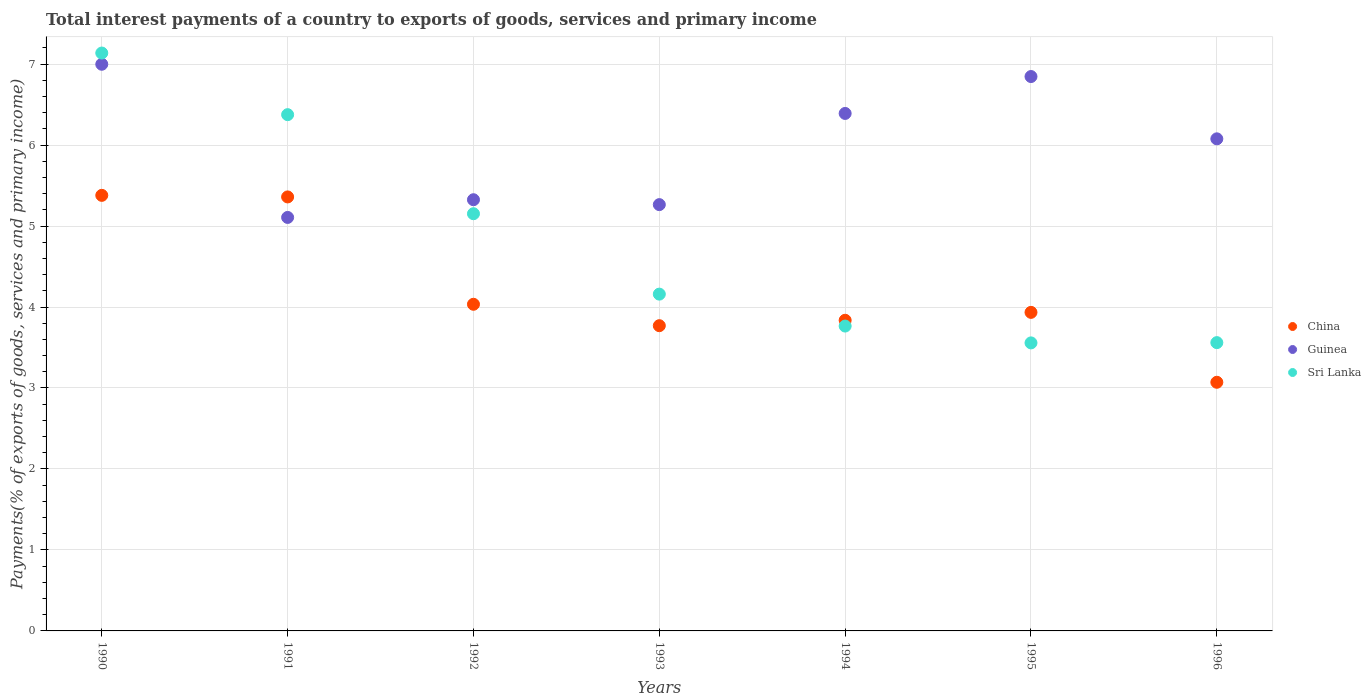How many different coloured dotlines are there?
Provide a succinct answer. 3. Is the number of dotlines equal to the number of legend labels?
Your answer should be very brief. Yes. What is the total interest payments in Sri Lanka in 1990?
Provide a succinct answer. 7.14. Across all years, what is the maximum total interest payments in Sri Lanka?
Provide a succinct answer. 7.14. Across all years, what is the minimum total interest payments in Sri Lanka?
Provide a short and direct response. 3.56. In which year was the total interest payments in Sri Lanka minimum?
Give a very brief answer. 1995. What is the total total interest payments in Guinea in the graph?
Keep it short and to the point. 42.01. What is the difference between the total interest payments in China in 1991 and that in 1993?
Provide a succinct answer. 1.59. What is the difference between the total interest payments in China in 1994 and the total interest payments in Sri Lanka in 1992?
Give a very brief answer. -1.32. What is the average total interest payments in Sri Lanka per year?
Your response must be concise. 4.81. In the year 1994, what is the difference between the total interest payments in China and total interest payments in Guinea?
Your response must be concise. -2.55. In how many years, is the total interest payments in Sri Lanka greater than 5 %?
Offer a very short reply. 3. What is the ratio of the total interest payments in Sri Lanka in 1990 to that in 1992?
Your answer should be compact. 1.39. Is the difference between the total interest payments in China in 1993 and 1995 greater than the difference between the total interest payments in Guinea in 1993 and 1995?
Give a very brief answer. Yes. What is the difference between the highest and the second highest total interest payments in Sri Lanka?
Ensure brevity in your answer.  0.76. What is the difference between the highest and the lowest total interest payments in China?
Make the answer very short. 2.31. In how many years, is the total interest payments in China greater than the average total interest payments in China taken over all years?
Your answer should be compact. 2. Does the total interest payments in Sri Lanka monotonically increase over the years?
Make the answer very short. No. Is the total interest payments in Sri Lanka strictly greater than the total interest payments in Guinea over the years?
Provide a succinct answer. No. How many dotlines are there?
Your answer should be very brief. 3. Are the values on the major ticks of Y-axis written in scientific E-notation?
Keep it short and to the point. No. Does the graph contain any zero values?
Ensure brevity in your answer.  No. Does the graph contain grids?
Provide a succinct answer. Yes. Where does the legend appear in the graph?
Give a very brief answer. Center right. How are the legend labels stacked?
Make the answer very short. Vertical. What is the title of the graph?
Offer a terse response. Total interest payments of a country to exports of goods, services and primary income. Does "Afghanistan" appear as one of the legend labels in the graph?
Your answer should be compact. No. What is the label or title of the X-axis?
Make the answer very short. Years. What is the label or title of the Y-axis?
Ensure brevity in your answer.  Payments(% of exports of goods, services and primary income). What is the Payments(% of exports of goods, services and primary income) in China in 1990?
Your answer should be compact. 5.38. What is the Payments(% of exports of goods, services and primary income) of Guinea in 1990?
Offer a terse response. 7. What is the Payments(% of exports of goods, services and primary income) of Sri Lanka in 1990?
Give a very brief answer. 7.14. What is the Payments(% of exports of goods, services and primary income) of China in 1991?
Provide a succinct answer. 5.36. What is the Payments(% of exports of goods, services and primary income) in Guinea in 1991?
Provide a succinct answer. 5.11. What is the Payments(% of exports of goods, services and primary income) in Sri Lanka in 1991?
Your answer should be very brief. 6.38. What is the Payments(% of exports of goods, services and primary income) in China in 1992?
Keep it short and to the point. 4.03. What is the Payments(% of exports of goods, services and primary income) in Guinea in 1992?
Offer a very short reply. 5.32. What is the Payments(% of exports of goods, services and primary income) of Sri Lanka in 1992?
Keep it short and to the point. 5.15. What is the Payments(% of exports of goods, services and primary income) in China in 1993?
Give a very brief answer. 3.77. What is the Payments(% of exports of goods, services and primary income) in Guinea in 1993?
Make the answer very short. 5.26. What is the Payments(% of exports of goods, services and primary income) of Sri Lanka in 1993?
Offer a very short reply. 4.16. What is the Payments(% of exports of goods, services and primary income) of China in 1994?
Provide a succinct answer. 3.84. What is the Payments(% of exports of goods, services and primary income) of Guinea in 1994?
Your answer should be very brief. 6.39. What is the Payments(% of exports of goods, services and primary income) of Sri Lanka in 1994?
Your answer should be compact. 3.76. What is the Payments(% of exports of goods, services and primary income) of China in 1995?
Offer a very short reply. 3.93. What is the Payments(% of exports of goods, services and primary income) in Guinea in 1995?
Give a very brief answer. 6.85. What is the Payments(% of exports of goods, services and primary income) of Sri Lanka in 1995?
Your answer should be compact. 3.56. What is the Payments(% of exports of goods, services and primary income) in China in 1996?
Give a very brief answer. 3.07. What is the Payments(% of exports of goods, services and primary income) of Guinea in 1996?
Offer a very short reply. 6.08. What is the Payments(% of exports of goods, services and primary income) in Sri Lanka in 1996?
Your response must be concise. 3.56. Across all years, what is the maximum Payments(% of exports of goods, services and primary income) in China?
Provide a succinct answer. 5.38. Across all years, what is the maximum Payments(% of exports of goods, services and primary income) of Guinea?
Offer a very short reply. 7. Across all years, what is the maximum Payments(% of exports of goods, services and primary income) in Sri Lanka?
Your response must be concise. 7.14. Across all years, what is the minimum Payments(% of exports of goods, services and primary income) in China?
Provide a short and direct response. 3.07. Across all years, what is the minimum Payments(% of exports of goods, services and primary income) of Guinea?
Ensure brevity in your answer.  5.11. Across all years, what is the minimum Payments(% of exports of goods, services and primary income) in Sri Lanka?
Your response must be concise. 3.56. What is the total Payments(% of exports of goods, services and primary income) of China in the graph?
Ensure brevity in your answer.  29.38. What is the total Payments(% of exports of goods, services and primary income) of Guinea in the graph?
Make the answer very short. 42.01. What is the total Payments(% of exports of goods, services and primary income) in Sri Lanka in the graph?
Give a very brief answer. 33.7. What is the difference between the Payments(% of exports of goods, services and primary income) of China in 1990 and that in 1991?
Ensure brevity in your answer.  0.02. What is the difference between the Payments(% of exports of goods, services and primary income) of Guinea in 1990 and that in 1991?
Provide a succinct answer. 1.89. What is the difference between the Payments(% of exports of goods, services and primary income) in Sri Lanka in 1990 and that in 1991?
Offer a terse response. 0.76. What is the difference between the Payments(% of exports of goods, services and primary income) of China in 1990 and that in 1992?
Ensure brevity in your answer.  1.34. What is the difference between the Payments(% of exports of goods, services and primary income) in Guinea in 1990 and that in 1992?
Ensure brevity in your answer.  1.67. What is the difference between the Payments(% of exports of goods, services and primary income) in Sri Lanka in 1990 and that in 1992?
Keep it short and to the point. 1.98. What is the difference between the Payments(% of exports of goods, services and primary income) in China in 1990 and that in 1993?
Ensure brevity in your answer.  1.61. What is the difference between the Payments(% of exports of goods, services and primary income) in Guinea in 1990 and that in 1993?
Keep it short and to the point. 1.73. What is the difference between the Payments(% of exports of goods, services and primary income) in Sri Lanka in 1990 and that in 1993?
Give a very brief answer. 2.98. What is the difference between the Payments(% of exports of goods, services and primary income) of China in 1990 and that in 1994?
Give a very brief answer. 1.54. What is the difference between the Payments(% of exports of goods, services and primary income) in Guinea in 1990 and that in 1994?
Your answer should be compact. 0.61. What is the difference between the Payments(% of exports of goods, services and primary income) in Sri Lanka in 1990 and that in 1994?
Ensure brevity in your answer.  3.37. What is the difference between the Payments(% of exports of goods, services and primary income) in China in 1990 and that in 1995?
Make the answer very short. 1.45. What is the difference between the Payments(% of exports of goods, services and primary income) in Guinea in 1990 and that in 1995?
Give a very brief answer. 0.15. What is the difference between the Payments(% of exports of goods, services and primary income) of Sri Lanka in 1990 and that in 1995?
Your answer should be very brief. 3.58. What is the difference between the Payments(% of exports of goods, services and primary income) of China in 1990 and that in 1996?
Ensure brevity in your answer.  2.31. What is the difference between the Payments(% of exports of goods, services and primary income) of Guinea in 1990 and that in 1996?
Provide a succinct answer. 0.92. What is the difference between the Payments(% of exports of goods, services and primary income) in Sri Lanka in 1990 and that in 1996?
Keep it short and to the point. 3.58. What is the difference between the Payments(% of exports of goods, services and primary income) in China in 1991 and that in 1992?
Your response must be concise. 1.33. What is the difference between the Payments(% of exports of goods, services and primary income) in Guinea in 1991 and that in 1992?
Give a very brief answer. -0.22. What is the difference between the Payments(% of exports of goods, services and primary income) of Sri Lanka in 1991 and that in 1992?
Provide a succinct answer. 1.22. What is the difference between the Payments(% of exports of goods, services and primary income) of China in 1991 and that in 1993?
Offer a very short reply. 1.59. What is the difference between the Payments(% of exports of goods, services and primary income) in Guinea in 1991 and that in 1993?
Give a very brief answer. -0.16. What is the difference between the Payments(% of exports of goods, services and primary income) of Sri Lanka in 1991 and that in 1993?
Provide a succinct answer. 2.22. What is the difference between the Payments(% of exports of goods, services and primary income) of China in 1991 and that in 1994?
Ensure brevity in your answer.  1.52. What is the difference between the Payments(% of exports of goods, services and primary income) in Guinea in 1991 and that in 1994?
Provide a succinct answer. -1.28. What is the difference between the Payments(% of exports of goods, services and primary income) in Sri Lanka in 1991 and that in 1994?
Your answer should be very brief. 2.61. What is the difference between the Payments(% of exports of goods, services and primary income) of China in 1991 and that in 1995?
Your response must be concise. 1.43. What is the difference between the Payments(% of exports of goods, services and primary income) in Guinea in 1991 and that in 1995?
Offer a very short reply. -1.74. What is the difference between the Payments(% of exports of goods, services and primary income) of Sri Lanka in 1991 and that in 1995?
Provide a succinct answer. 2.82. What is the difference between the Payments(% of exports of goods, services and primary income) of China in 1991 and that in 1996?
Keep it short and to the point. 2.29. What is the difference between the Payments(% of exports of goods, services and primary income) in Guinea in 1991 and that in 1996?
Your answer should be compact. -0.97. What is the difference between the Payments(% of exports of goods, services and primary income) of Sri Lanka in 1991 and that in 1996?
Your response must be concise. 2.82. What is the difference between the Payments(% of exports of goods, services and primary income) in China in 1992 and that in 1993?
Provide a succinct answer. 0.26. What is the difference between the Payments(% of exports of goods, services and primary income) of Guinea in 1992 and that in 1993?
Offer a terse response. 0.06. What is the difference between the Payments(% of exports of goods, services and primary income) of Sri Lanka in 1992 and that in 1993?
Provide a short and direct response. 0.99. What is the difference between the Payments(% of exports of goods, services and primary income) in China in 1992 and that in 1994?
Your answer should be compact. 0.2. What is the difference between the Payments(% of exports of goods, services and primary income) of Guinea in 1992 and that in 1994?
Provide a short and direct response. -1.07. What is the difference between the Payments(% of exports of goods, services and primary income) in Sri Lanka in 1992 and that in 1994?
Ensure brevity in your answer.  1.39. What is the difference between the Payments(% of exports of goods, services and primary income) of China in 1992 and that in 1995?
Your response must be concise. 0.1. What is the difference between the Payments(% of exports of goods, services and primary income) of Guinea in 1992 and that in 1995?
Make the answer very short. -1.52. What is the difference between the Payments(% of exports of goods, services and primary income) of Sri Lanka in 1992 and that in 1995?
Your answer should be very brief. 1.6. What is the difference between the Payments(% of exports of goods, services and primary income) of China in 1992 and that in 1996?
Offer a very short reply. 0.96. What is the difference between the Payments(% of exports of goods, services and primary income) of Guinea in 1992 and that in 1996?
Give a very brief answer. -0.75. What is the difference between the Payments(% of exports of goods, services and primary income) in Sri Lanka in 1992 and that in 1996?
Offer a terse response. 1.59. What is the difference between the Payments(% of exports of goods, services and primary income) of China in 1993 and that in 1994?
Offer a terse response. -0.07. What is the difference between the Payments(% of exports of goods, services and primary income) in Guinea in 1993 and that in 1994?
Your answer should be very brief. -1.13. What is the difference between the Payments(% of exports of goods, services and primary income) of Sri Lanka in 1993 and that in 1994?
Your response must be concise. 0.39. What is the difference between the Payments(% of exports of goods, services and primary income) of China in 1993 and that in 1995?
Offer a terse response. -0.16. What is the difference between the Payments(% of exports of goods, services and primary income) of Guinea in 1993 and that in 1995?
Provide a short and direct response. -1.58. What is the difference between the Payments(% of exports of goods, services and primary income) of Sri Lanka in 1993 and that in 1995?
Your answer should be very brief. 0.6. What is the difference between the Payments(% of exports of goods, services and primary income) of China in 1993 and that in 1996?
Offer a very short reply. 0.7. What is the difference between the Payments(% of exports of goods, services and primary income) of Guinea in 1993 and that in 1996?
Offer a terse response. -0.81. What is the difference between the Payments(% of exports of goods, services and primary income) in Sri Lanka in 1993 and that in 1996?
Give a very brief answer. 0.6. What is the difference between the Payments(% of exports of goods, services and primary income) in China in 1994 and that in 1995?
Give a very brief answer. -0.1. What is the difference between the Payments(% of exports of goods, services and primary income) of Guinea in 1994 and that in 1995?
Ensure brevity in your answer.  -0.46. What is the difference between the Payments(% of exports of goods, services and primary income) in Sri Lanka in 1994 and that in 1995?
Give a very brief answer. 0.21. What is the difference between the Payments(% of exports of goods, services and primary income) in China in 1994 and that in 1996?
Your answer should be very brief. 0.77. What is the difference between the Payments(% of exports of goods, services and primary income) of Guinea in 1994 and that in 1996?
Your answer should be compact. 0.31. What is the difference between the Payments(% of exports of goods, services and primary income) of Sri Lanka in 1994 and that in 1996?
Make the answer very short. 0.2. What is the difference between the Payments(% of exports of goods, services and primary income) in China in 1995 and that in 1996?
Provide a short and direct response. 0.86. What is the difference between the Payments(% of exports of goods, services and primary income) of Guinea in 1995 and that in 1996?
Offer a terse response. 0.77. What is the difference between the Payments(% of exports of goods, services and primary income) of Sri Lanka in 1995 and that in 1996?
Provide a succinct answer. -0. What is the difference between the Payments(% of exports of goods, services and primary income) in China in 1990 and the Payments(% of exports of goods, services and primary income) in Guinea in 1991?
Your answer should be very brief. 0.27. What is the difference between the Payments(% of exports of goods, services and primary income) in China in 1990 and the Payments(% of exports of goods, services and primary income) in Sri Lanka in 1991?
Ensure brevity in your answer.  -1. What is the difference between the Payments(% of exports of goods, services and primary income) of Guinea in 1990 and the Payments(% of exports of goods, services and primary income) of Sri Lanka in 1991?
Your answer should be very brief. 0.62. What is the difference between the Payments(% of exports of goods, services and primary income) in China in 1990 and the Payments(% of exports of goods, services and primary income) in Guinea in 1992?
Offer a very short reply. 0.05. What is the difference between the Payments(% of exports of goods, services and primary income) in China in 1990 and the Payments(% of exports of goods, services and primary income) in Sri Lanka in 1992?
Provide a succinct answer. 0.23. What is the difference between the Payments(% of exports of goods, services and primary income) of Guinea in 1990 and the Payments(% of exports of goods, services and primary income) of Sri Lanka in 1992?
Your response must be concise. 1.85. What is the difference between the Payments(% of exports of goods, services and primary income) in China in 1990 and the Payments(% of exports of goods, services and primary income) in Guinea in 1993?
Keep it short and to the point. 0.11. What is the difference between the Payments(% of exports of goods, services and primary income) in China in 1990 and the Payments(% of exports of goods, services and primary income) in Sri Lanka in 1993?
Your response must be concise. 1.22. What is the difference between the Payments(% of exports of goods, services and primary income) in Guinea in 1990 and the Payments(% of exports of goods, services and primary income) in Sri Lanka in 1993?
Keep it short and to the point. 2.84. What is the difference between the Payments(% of exports of goods, services and primary income) in China in 1990 and the Payments(% of exports of goods, services and primary income) in Guinea in 1994?
Offer a terse response. -1.01. What is the difference between the Payments(% of exports of goods, services and primary income) in China in 1990 and the Payments(% of exports of goods, services and primary income) in Sri Lanka in 1994?
Give a very brief answer. 1.61. What is the difference between the Payments(% of exports of goods, services and primary income) in Guinea in 1990 and the Payments(% of exports of goods, services and primary income) in Sri Lanka in 1994?
Provide a succinct answer. 3.23. What is the difference between the Payments(% of exports of goods, services and primary income) of China in 1990 and the Payments(% of exports of goods, services and primary income) of Guinea in 1995?
Provide a short and direct response. -1.47. What is the difference between the Payments(% of exports of goods, services and primary income) in China in 1990 and the Payments(% of exports of goods, services and primary income) in Sri Lanka in 1995?
Keep it short and to the point. 1.82. What is the difference between the Payments(% of exports of goods, services and primary income) of Guinea in 1990 and the Payments(% of exports of goods, services and primary income) of Sri Lanka in 1995?
Provide a short and direct response. 3.44. What is the difference between the Payments(% of exports of goods, services and primary income) of China in 1990 and the Payments(% of exports of goods, services and primary income) of Guinea in 1996?
Provide a succinct answer. -0.7. What is the difference between the Payments(% of exports of goods, services and primary income) of China in 1990 and the Payments(% of exports of goods, services and primary income) of Sri Lanka in 1996?
Your answer should be very brief. 1.82. What is the difference between the Payments(% of exports of goods, services and primary income) in Guinea in 1990 and the Payments(% of exports of goods, services and primary income) in Sri Lanka in 1996?
Give a very brief answer. 3.44. What is the difference between the Payments(% of exports of goods, services and primary income) in China in 1991 and the Payments(% of exports of goods, services and primary income) in Guinea in 1992?
Keep it short and to the point. 0.03. What is the difference between the Payments(% of exports of goods, services and primary income) in China in 1991 and the Payments(% of exports of goods, services and primary income) in Sri Lanka in 1992?
Your answer should be very brief. 0.21. What is the difference between the Payments(% of exports of goods, services and primary income) of Guinea in 1991 and the Payments(% of exports of goods, services and primary income) of Sri Lanka in 1992?
Keep it short and to the point. -0.05. What is the difference between the Payments(% of exports of goods, services and primary income) of China in 1991 and the Payments(% of exports of goods, services and primary income) of Guinea in 1993?
Provide a short and direct response. 0.1. What is the difference between the Payments(% of exports of goods, services and primary income) of China in 1991 and the Payments(% of exports of goods, services and primary income) of Sri Lanka in 1993?
Offer a terse response. 1.2. What is the difference between the Payments(% of exports of goods, services and primary income) of Guinea in 1991 and the Payments(% of exports of goods, services and primary income) of Sri Lanka in 1993?
Offer a very short reply. 0.95. What is the difference between the Payments(% of exports of goods, services and primary income) of China in 1991 and the Payments(% of exports of goods, services and primary income) of Guinea in 1994?
Your answer should be compact. -1.03. What is the difference between the Payments(% of exports of goods, services and primary income) of China in 1991 and the Payments(% of exports of goods, services and primary income) of Sri Lanka in 1994?
Give a very brief answer. 1.59. What is the difference between the Payments(% of exports of goods, services and primary income) in Guinea in 1991 and the Payments(% of exports of goods, services and primary income) in Sri Lanka in 1994?
Provide a short and direct response. 1.34. What is the difference between the Payments(% of exports of goods, services and primary income) of China in 1991 and the Payments(% of exports of goods, services and primary income) of Guinea in 1995?
Your response must be concise. -1.49. What is the difference between the Payments(% of exports of goods, services and primary income) in China in 1991 and the Payments(% of exports of goods, services and primary income) in Sri Lanka in 1995?
Provide a short and direct response. 1.8. What is the difference between the Payments(% of exports of goods, services and primary income) in Guinea in 1991 and the Payments(% of exports of goods, services and primary income) in Sri Lanka in 1995?
Offer a terse response. 1.55. What is the difference between the Payments(% of exports of goods, services and primary income) of China in 1991 and the Payments(% of exports of goods, services and primary income) of Guinea in 1996?
Provide a short and direct response. -0.72. What is the difference between the Payments(% of exports of goods, services and primary income) of China in 1991 and the Payments(% of exports of goods, services and primary income) of Sri Lanka in 1996?
Make the answer very short. 1.8. What is the difference between the Payments(% of exports of goods, services and primary income) in Guinea in 1991 and the Payments(% of exports of goods, services and primary income) in Sri Lanka in 1996?
Ensure brevity in your answer.  1.55. What is the difference between the Payments(% of exports of goods, services and primary income) of China in 1992 and the Payments(% of exports of goods, services and primary income) of Guinea in 1993?
Provide a succinct answer. -1.23. What is the difference between the Payments(% of exports of goods, services and primary income) in China in 1992 and the Payments(% of exports of goods, services and primary income) in Sri Lanka in 1993?
Offer a very short reply. -0.13. What is the difference between the Payments(% of exports of goods, services and primary income) of Guinea in 1992 and the Payments(% of exports of goods, services and primary income) of Sri Lanka in 1993?
Offer a terse response. 1.17. What is the difference between the Payments(% of exports of goods, services and primary income) of China in 1992 and the Payments(% of exports of goods, services and primary income) of Guinea in 1994?
Provide a short and direct response. -2.36. What is the difference between the Payments(% of exports of goods, services and primary income) of China in 1992 and the Payments(% of exports of goods, services and primary income) of Sri Lanka in 1994?
Ensure brevity in your answer.  0.27. What is the difference between the Payments(% of exports of goods, services and primary income) in Guinea in 1992 and the Payments(% of exports of goods, services and primary income) in Sri Lanka in 1994?
Your answer should be compact. 1.56. What is the difference between the Payments(% of exports of goods, services and primary income) in China in 1992 and the Payments(% of exports of goods, services and primary income) in Guinea in 1995?
Ensure brevity in your answer.  -2.81. What is the difference between the Payments(% of exports of goods, services and primary income) in China in 1992 and the Payments(% of exports of goods, services and primary income) in Sri Lanka in 1995?
Your answer should be very brief. 0.48. What is the difference between the Payments(% of exports of goods, services and primary income) in Guinea in 1992 and the Payments(% of exports of goods, services and primary income) in Sri Lanka in 1995?
Offer a terse response. 1.77. What is the difference between the Payments(% of exports of goods, services and primary income) of China in 1992 and the Payments(% of exports of goods, services and primary income) of Guinea in 1996?
Ensure brevity in your answer.  -2.04. What is the difference between the Payments(% of exports of goods, services and primary income) of China in 1992 and the Payments(% of exports of goods, services and primary income) of Sri Lanka in 1996?
Offer a very short reply. 0.47. What is the difference between the Payments(% of exports of goods, services and primary income) in Guinea in 1992 and the Payments(% of exports of goods, services and primary income) in Sri Lanka in 1996?
Ensure brevity in your answer.  1.76. What is the difference between the Payments(% of exports of goods, services and primary income) in China in 1993 and the Payments(% of exports of goods, services and primary income) in Guinea in 1994?
Offer a very short reply. -2.62. What is the difference between the Payments(% of exports of goods, services and primary income) in China in 1993 and the Payments(% of exports of goods, services and primary income) in Sri Lanka in 1994?
Give a very brief answer. 0. What is the difference between the Payments(% of exports of goods, services and primary income) of Guinea in 1993 and the Payments(% of exports of goods, services and primary income) of Sri Lanka in 1994?
Provide a short and direct response. 1.5. What is the difference between the Payments(% of exports of goods, services and primary income) of China in 1993 and the Payments(% of exports of goods, services and primary income) of Guinea in 1995?
Provide a short and direct response. -3.08. What is the difference between the Payments(% of exports of goods, services and primary income) in China in 1993 and the Payments(% of exports of goods, services and primary income) in Sri Lanka in 1995?
Provide a succinct answer. 0.21. What is the difference between the Payments(% of exports of goods, services and primary income) in Guinea in 1993 and the Payments(% of exports of goods, services and primary income) in Sri Lanka in 1995?
Your answer should be compact. 1.71. What is the difference between the Payments(% of exports of goods, services and primary income) in China in 1993 and the Payments(% of exports of goods, services and primary income) in Guinea in 1996?
Keep it short and to the point. -2.31. What is the difference between the Payments(% of exports of goods, services and primary income) in China in 1993 and the Payments(% of exports of goods, services and primary income) in Sri Lanka in 1996?
Give a very brief answer. 0.21. What is the difference between the Payments(% of exports of goods, services and primary income) of Guinea in 1993 and the Payments(% of exports of goods, services and primary income) of Sri Lanka in 1996?
Make the answer very short. 1.7. What is the difference between the Payments(% of exports of goods, services and primary income) in China in 1994 and the Payments(% of exports of goods, services and primary income) in Guinea in 1995?
Give a very brief answer. -3.01. What is the difference between the Payments(% of exports of goods, services and primary income) in China in 1994 and the Payments(% of exports of goods, services and primary income) in Sri Lanka in 1995?
Your answer should be compact. 0.28. What is the difference between the Payments(% of exports of goods, services and primary income) in Guinea in 1994 and the Payments(% of exports of goods, services and primary income) in Sri Lanka in 1995?
Offer a terse response. 2.83. What is the difference between the Payments(% of exports of goods, services and primary income) in China in 1994 and the Payments(% of exports of goods, services and primary income) in Guinea in 1996?
Your response must be concise. -2.24. What is the difference between the Payments(% of exports of goods, services and primary income) of China in 1994 and the Payments(% of exports of goods, services and primary income) of Sri Lanka in 1996?
Give a very brief answer. 0.28. What is the difference between the Payments(% of exports of goods, services and primary income) of Guinea in 1994 and the Payments(% of exports of goods, services and primary income) of Sri Lanka in 1996?
Ensure brevity in your answer.  2.83. What is the difference between the Payments(% of exports of goods, services and primary income) of China in 1995 and the Payments(% of exports of goods, services and primary income) of Guinea in 1996?
Your answer should be compact. -2.14. What is the difference between the Payments(% of exports of goods, services and primary income) of China in 1995 and the Payments(% of exports of goods, services and primary income) of Sri Lanka in 1996?
Provide a short and direct response. 0.37. What is the difference between the Payments(% of exports of goods, services and primary income) in Guinea in 1995 and the Payments(% of exports of goods, services and primary income) in Sri Lanka in 1996?
Your answer should be compact. 3.29. What is the average Payments(% of exports of goods, services and primary income) of China per year?
Offer a terse response. 4.2. What is the average Payments(% of exports of goods, services and primary income) in Guinea per year?
Your answer should be compact. 6. What is the average Payments(% of exports of goods, services and primary income) of Sri Lanka per year?
Give a very brief answer. 4.81. In the year 1990, what is the difference between the Payments(% of exports of goods, services and primary income) of China and Payments(% of exports of goods, services and primary income) of Guinea?
Ensure brevity in your answer.  -1.62. In the year 1990, what is the difference between the Payments(% of exports of goods, services and primary income) in China and Payments(% of exports of goods, services and primary income) in Sri Lanka?
Ensure brevity in your answer.  -1.76. In the year 1990, what is the difference between the Payments(% of exports of goods, services and primary income) in Guinea and Payments(% of exports of goods, services and primary income) in Sri Lanka?
Offer a very short reply. -0.14. In the year 1991, what is the difference between the Payments(% of exports of goods, services and primary income) in China and Payments(% of exports of goods, services and primary income) in Guinea?
Ensure brevity in your answer.  0.25. In the year 1991, what is the difference between the Payments(% of exports of goods, services and primary income) of China and Payments(% of exports of goods, services and primary income) of Sri Lanka?
Make the answer very short. -1.02. In the year 1991, what is the difference between the Payments(% of exports of goods, services and primary income) of Guinea and Payments(% of exports of goods, services and primary income) of Sri Lanka?
Your response must be concise. -1.27. In the year 1992, what is the difference between the Payments(% of exports of goods, services and primary income) in China and Payments(% of exports of goods, services and primary income) in Guinea?
Your answer should be very brief. -1.29. In the year 1992, what is the difference between the Payments(% of exports of goods, services and primary income) of China and Payments(% of exports of goods, services and primary income) of Sri Lanka?
Offer a terse response. -1.12. In the year 1992, what is the difference between the Payments(% of exports of goods, services and primary income) in Guinea and Payments(% of exports of goods, services and primary income) in Sri Lanka?
Your answer should be very brief. 0.17. In the year 1993, what is the difference between the Payments(% of exports of goods, services and primary income) in China and Payments(% of exports of goods, services and primary income) in Guinea?
Offer a very short reply. -1.5. In the year 1993, what is the difference between the Payments(% of exports of goods, services and primary income) of China and Payments(% of exports of goods, services and primary income) of Sri Lanka?
Give a very brief answer. -0.39. In the year 1993, what is the difference between the Payments(% of exports of goods, services and primary income) of Guinea and Payments(% of exports of goods, services and primary income) of Sri Lanka?
Make the answer very short. 1.11. In the year 1994, what is the difference between the Payments(% of exports of goods, services and primary income) in China and Payments(% of exports of goods, services and primary income) in Guinea?
Offer a terse response. -2.55. In the year 1994, what is the difference between the Payments(% of exports of goods, services and primary income) in China and Payments(% of exports of goods, services and primary income) in Sri Lanka?
Your answer should be compact. 0.07. In the year 1994, what is the difference between the Payments(% of exports of goods, services and primary income) in Guinea and Payments(% of exports of goods, services and primary income) in Sri Lanka?
Make the answer very short. 2.63. In the year 1995, what is the difference between the Payments(% of exports of goods, services and primary income) in China and Payments(% of exports of goods, services and primary income) in Guinea?
Ensure brevity in your answer.  -2.91. In the year 1995, what is the difference between the Payments(% of exports of goods, services and primary income) of China and Payments(% of exports of goods, services and primary income) of Sri Lanka?
Your answer should be compact. 0.38. In the year 1995, what is the difference between the Payments(% of exports of goods, services and primary income) of Guinea and Payments(% of exports of goods, services and primary income) of Sri Lanka?
Offer a very short reply. 3.29. In the year 1996, what is the difference between the Payments(% of exports of goods, services and primary income) in China and Payments(% of exports of goods, services and primary income) in Guinea?
Make the answer very short. -3.01. In the year 1996, what is the difference between the Payments(% of exports of goods, services and primary income) in China and Payments(% of exports of goods, services and primary income) in Sri Lanka?
Provide a succinct answer. -0.49. In the year 1996, what is the difference between the Payments(% of exports of goods, services and primary income) in Guinea and Payments(% of exports of goods, services and primary income) in Sri Lanka?
Ensure brevity in your answer.  2.52. What is the ratio of the Payments(% of exports of goods, services and primary income) in Guinea in 1990 to that in 1991?
Your answer should be compact. 1.37. What is the ratio of the Payments(% of exports of goods, services and primary income) of Sri Lanka in 1990 to that in 1991?
Make the answer very short. 1.12. What is the ratio of the Payments(% of exports of goods, services and primary income) in China in 1990 to that in 1992?
Offer a very short reply. 1.33. What is the ratio of the Payments(% of exports of goods, services and primary income) of Guinea in 1990 to that in 1992?
Your answer should be very brief. 1.31. What is the ratio of the Payments(% of exports of goods, services and primary income) in Sri Lanka in 1990 to that in 1992?
Your answer should be compact. 1.39. What is the ratio of the Payments(% of exports of goods, services and primary income) in China in 1990 to that in 1993?
Provide a short and direct response. 1.43. What is the ratio of the Payments(% of exports of goods, services and primary income) in Guinea in 1990 to that in 1993?
Your answer should be compact. 1.33. What is the ratio of the Payments(% of exports of goods, services and primary income) of Sri Lanka in 1990 to that in 1993?
Ensure brevity in your answer.  1.72. What is the ratio of the Payments(% of exports of goods, services and primary income) in China in 1990 to that in 1994?
Your answer should be compact. 1.4. What is the ratio of the Payments(% of exports of goods, services and primary income) of Guinea in 1990 to that in 1994?
Keep it short and to the point. 1.1. What is the ratio of the Payments(% of exports of goods, services and primary income) of Sri Lanka in 1990 to that in 1994?
Offer a very short reply. 1.9. What is the ratio of the Payments(% of exports of goods, services and primary income) in China in 1990 to that in 1995?
Your answer should be compact. 1.37. What is the ratio of the Payments(% of exports of goods, services and primary income) in Guinea in 1990 to that in 1995?
Make the answer very short. 1.02. What is the ratio of the Payments(% of exports of goods, services and primary income) of Sri Lanka in 1990 to that in 1995?
Offer a very short reply. 2.01. What is the ratio of the Payments(% of exports of goods, services and primary income) in China in 1990 to that in 1996?
Offer a terse response. 1.75. What is the ratio of the Payments(% of exports of goods, services and primary income) in Guinea in 1990 to that in 1996?
Your answer should be compact. 1.15. What is the ratio of the Payments(% of exports of goods, services and primary income) in Sri Lanka in 1990 to that in 1996?
Provide a short and direct response. 2. What is the ratio of the Payments(% of exports of goods, services and primary income) of China in 1991 to that in 1992?
Make the answer very short. 1.33. What is the ratio of the Payments(% of exports of goods, services and primary income) of Guinea in 1991 to that in 1992?
Your response must be concise. 0.96. What is the ratio of the Payments(% of exports of goods, services and primary income) of Sri Lanka in 1991 to that in 1992?
Your response must be concise. 1.24. What is the ratio of the Payments(% of exports of goods, services and primary income) in China in 1991 to that in 1993?
Make the answer very short. 1.42. What is the ratio of the Payments(% of exports of goods, services and primary income) in Guinea in 1991 to that in 1993?
Your answer should be very brief. 0.97. What is the ratio of the Payments(% of exports of goods, services and primary income) of Sri Lanka in 1991 to that in 1993?
Your answer should be very brief. 1.53. What is the ratio of the Payments(% of exports of goods, services and primary income) of China in 1991 to that in 1994?
Offer a terse response. 1.4. What is the ratio of the Payments(% of exports of goods, services and primary income) in Guinea in 1991 to that in 1994?
Offer a very short reply. 0.8. What is the ratio of the Payments(% of exports of goods, services and primary income) in Sri Lanka in 1991 to that in 1994?
Ensure brevity in your answer.  1.69. What is the ratio of the Payments(% of exports of goods, services and primary income) in China in 1991 to that in 1995?
Your answer should be compact. 1.36. What is the ratio of the Payments(% of exports of goods, services and primary income) of Guinea in 1991 to that in 1995?
Your answer should be very brief. 0.75. What is the ratio of the Payments(% of exports of goods, services and primary income) of Sri Lanka in 1991 to that in 1995?
Your answer should be compact. 1.79. What is the ratio of the Payments(% of exports of goods, services and primary income) of China in 1991 to that in 1996?
Make the answer very short. 1.75. What is the ratio of the Payments(% of exports of goods, services and primary income) of Guinea in 1991 to that in 1996?
Provide a succinct answer. 0.84. What is the ratio of the Payments(% of exports of goods, services and primary income) of Sri Lanka in 1991 to that in 1996?
Provide a succinct answer. 1.79. What is the ratio of the Payments(% of exports of goods, services and primary income) of China in 1992 to that in 1993?
Ensure brevity in your answer.  1.07. What is the ratio of the Payments(% of exports of goods, services and primary income) of Guinea in 1992 to that in 1993?
Your response must be concise. 1.01. What is the ratio of the Payments(% of exports of goods, services and primary income) of Sri Lanka in 1992 to that in 1993?
Ensure brevity in your answer.  1.24. What is the ratio of the Payments(% of exports of goods, services and primary income) in China in 1992 to that in 1994?
Give a very brief answer. 1.05. What is the ratio of the Payments(% of exports of goods, services and primary income) of Sri Lanka in 1992 to that in 1994?
Ensure brevity in your answer.  1.37. What is the ratio of the Payments(% of exports of goods, services and primary income) in China in 1992 to that in 1995?
Provide a short and direct response. 1.03. What is the ratio of the Payments(% of exports of goods, services and primary income) in Guinea in 1992 to that in 1995?
Offer a terse response. 0.78. What is the ratio of the Payments(% of exports of goods, services and primary income) in Sri Lanka in 1992 to that in 1995?
Give a very brief answer. 1.45. What is the ratio of the Payments(% of exports of goods, services and primary income) of China in 1992 to that in 1996?
Keep it short and to the point. 1.31. What is the ratio of the Payments(% of exports of goods, services and primary income) in Guinea in 1992 to that in 1996?
Keep it short and to the point. 0.88. What is the ratio of the Payments(% of exports of goods, services and primary income) of Sri Lanka in 1992 to that in 1996?
Keep it short and to the point. 1.45. What is the ratio of the Payments(% of exports of goods, services and primary income) in China in 1993 to that in 1994?
Your answer should be compact. 0.98. What is the ratio of the Payments(% of exports of goods, services and primary income) in Guinea in 1993 to that in 1994?
Provide a succinct answer. 0.82. What is the ratio of the Payments(% of exports of goods, services and primary income) of Sri Lanka in 1993 to that in 1994?
Your answer should be compact. 1.1. What is the ratio of the Payments(% of exports of goods, services and primary income) in China in 1993 to that in 1995?
Your response must be concise. 0.96. What is the ratio of the Payments(% of exports of goods, services and primary income) of Guinea in 1993 to that in 1995?
Ensure brevity in your answer.  0.77. What is the ratio of the Payments(% of exports of goods, services and primary income) in Sri Lanka in 1993 to that in 1995?
Offer a very short reply. 1.17. What is the ratio of the Payments(% of exports of goods, services and primary income) in China in 1993 to that in 1996?
Ensure brevity in your answer.  1.23. What is the ratio of the Payments(% of exports of goods, services and primary income) in Guinea in 1993 to that in 1996?
Ensure brevity in your answer.  0.87. What is the ratio of the Payments(% of exports of goods, services and primary income) in Sri Lanka in 1993 to that in 1996?
Offer a very short reply. 1.17. What is the ratio of the Payments(% of exports of goods, services and primary income) in China in 1994 to that in 1995?
Make the answer very short. 0.98. What is the ratio of the Payments(% of exports of goods, services and primary income) of Guinea in 1994 to that in 1995?
Offer a terse response. 0.93. What is the ratio of the Payments(% of exports of goods, services and primary income) of Sri Lanka in 1994 to that in 1995?
Offer a terse response. 1.06. What is the ratio of the Payments(% of exports of goods, services and primary income) in China in 1994 to that in 1996?
Give a very brief answer. 1.25. What is the ratio of the Payments(% of exports of goods, services and primary income) in Guinea in 1994 to that in 1996?
Offer a terse response. 1.05. What is the ratio of the Payments(% of exports of goods, services and primary income) in Sri Lanka in 1994 to that in 1996?
Offer a very short reply. 1.06. What is the ratio of the Payments(% of exports of goods, services and primary income) of China in 1995 to that in 1996?
Make the answer very short. 1.28. What is the ratio of the Payments(% of exports of goods, services and primary income) of Guinea in 1995 to that in 1996?
Ensure brevity in your answer.  1.13. What is the difference between the highest and the second highest Payments(% of exports of goods, services and primary income) in China?
Make the answer very short. 0.02. What is the difference between the highest and the second highest Payments(% of exports of goods, services and primary income) of Guinea?
Your answer should be very brief. 0.15. What is the difference between the highest and the second highest Payments(% of exports of goods, services and primary income) in Sri Lanka?
Provide a short and direct response. 0.76. What is the difference between the highest and the lowest Payments(% of exports of goods, services and primary income) of China?
Provide a short and direct response. 2.31. What is the difference between the highest and the lowest Payments(% of exports of goods, services and primary income) in Guinea?
Offer a very short reply. 1.89. What is the difference between the highest and the lowest Payments(% of exports of goods, services and primary income) of Sri Lanka?
Ensure brevity in your answer.  3.58. 